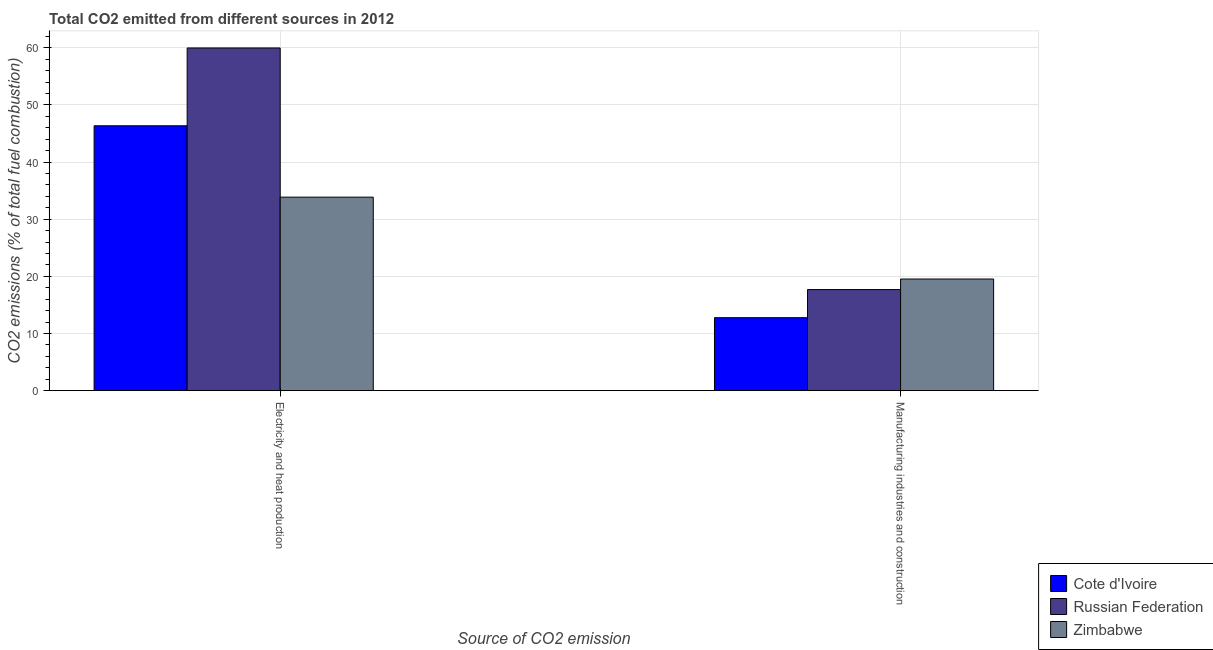How many different coloured bars are there?
Keep it short and to the point. 3. How many groups of bars are there?
Your response must be concise. 2. Are the number of bars per tick equal to the number of legend labels?
Make the answer very short. Yes. Are the number of bars on each tick of the X-axis equal?
Your answer should be very brief. Yes. How many bars are there on the 2nd tick from the right?
Keep it short and to the point. 3. What is the label of the 2nd group of bars from the left?
Offer a very short reply. Manufacturing industries and construction. What is the co2 emissions due to manufacturing industries in Zimbabwe?
Keep it short and to the point. 19.54. Across all countries, what is the maximum co2 emissions due to manufacturing industries?
Give a very brief answer. 19.54. Across all countries, what is the minimum co2 emissions due to electricity and heat production?
Keep it short and to the point. 33.87. In which country was the co2 emissions due to electricity and heat production maximum?
Provide a succinct answer. Russian Federation. In which country was the co2 emissions due to manufacturing industries minimum?
Offer a terse response. Cote d'Ivoire. What is the total co2 emissions due to electricity and heat production in the graph?
Make the answer very short. 140.21. What is the difference between the co2 emissions due to electricity and heat production in Russian Federation and that in Zimbabwe?
Offer a terse response. 26.11. What is the difference between the co2 emissions due to manufacturing industries in Russian Federation and the co2 emissions due to electricity and heat production in Cote d'Ivoire?
Provide a succinct answer. -28.67. What is the average co2 emissions due to manufacturing industries per country?
Keep it short and to the point. 16.67. What is the difference between the co2 emissions due to manufacturing industries and co2 emissions due to electricity and heat production in Zimbabwe?
Your answer should be compact. -14.33. What is the ratio of the co2 emissions due to electricity and heat production in Zimbabwe to that in Cote d'Ivoire?
Your answer should be compact. 0.73. In how many countries, is the co2 emissions due to manufacturing industries greater than the average co2 emissions due to manufacturing industries taken over all countries?
Ensure brevity in your answer.  2. What does the 3rd bar from the left in Electricity and heat production represents?
Give a very brief answer. Zimbabwe. What does the 3rd bar from the right in Manufacturing industries and construction represents?
Give a very brief answer. Cote d'Ivoire. How many countries are there in the graph?
Your answer should be compact. 3. What is the difference between two consecutive major ticks on the Y-axis?
Give a very brief answer. 10. Are the values on the major ticks of Y-axis written in scientific E-notation?
Make the answer very short. No. Does the graph contain any zero values?
Give a very brief answer. No. Does the graph contain grids?
Provide a short and direct response. Yes. How many legend labels are there?
Provide a short and direct response. 3. How are the legend labels stacked?
Ensure brevity in your answer.  Vertical. What is the title of the graph?
Give a very brief answer. Total CO2 emitted from different sources in 2012. What is the label or title of the X-axis?
Your response must be concise. Source of CO2 emission. What is the label or title of the Y-axis?
Make the answer very short. CO2 emissions (% of total fuel combustion). What is the CO2 emissions (% of total fuel combustion) in Cote d'Ivoire in Electricity and heat production?
Your answer should be compact. 46.36. What is the CO2 emissions (% of total fuel combustion) in Russian Federation in Electricity and heat production?
Offer a very short reply. 59.98. What is the CO2 emissions (% of total fuel combustion) of Zimbabwe in Electricity and heat production?
Your answer should be compact. 33.87. What is the CO2 emissions (% of total fuel combustion) of Cote d'Ivoire in Manufacturing industries and construction?
Provide a short and direct response. 12.77. What is the CO2 emissions (% of total fuel combustion) in Russian Federation in Manufacturing industries and construction?
Provide a short and direct response. 17.69. What is the CO2 emissions (% of total fuel combustion) of Zimbabwe in Manufacturing industries and construction?
Your response must be concise. 19.54. Across all Source of CO2 emission, what is the maximum CO2 emissions (% of total fuel combustion) of Cote d'Ivoire?
Ensure brevity in your answer.  46.36. Across all Source of CO2 emission, what is the maximum CO2 emissions (% of total fuel combustion) of Russian Federation?
Your answer should be very brief. 59.98. Across all Source of CO2 emission, what is the maximum CO2 emissions (% of total fuel combustion) in Zimbabwe?
Keep it short and to the point. 33.87. Across all Source of CO2 emission, what is the minimum CO2 emissions (% of total fuel combustion) in Cote d'Ivoire?
Make the answer very short. 12.77. Across all Source of CO2 emission, what is the minimum CO2 emissions (% of total fuel combustion) of Russian Federation?
Ensure brevity in your answer.  17.69. Across all Source of CO2 emission, what is the minimum CO2 emissions (% of total fuel combustion) in Zimbabwe?
Make the answer very short. 19.54. What is the total CO2 emissions (% of total fuel combustion) of Cote d'Ivoire in the graph?
Give a very brief answer. 59.13. What is the total CO2 emissions (% of total fuel combustion) of Russian Federation in the graph?
Give a very brief answer. 77.67. What is the total CO2 emissions (% of total fuel combustion) of Zimbabwe in the graph?
Offer a terse response. 53.41. What is the difference between the CO2 emissions (% of total fuel combustion) in Cote d'Ivoire in Electricity and heat production and that in Manufacturing industries and construction?
Provide a succinct answer. 33.59. What is the difference between the CO2 emissions (% of total fuel combustion) of Russian Federation in Electricity and heat production and that in Manufacturing industries and construction?
Provide a succinct answer. 42.29. What is the difference between the CO2 emissions (% of total fuel combustion) in Zimbabwe in Electricity and heat production and that in Manufacturing industries and construction?
Keep it short and to the point. 14.33. What is the difference between the CO2 emissions (% of total fuel combustion) of Cote d'Ivoire in Electricity and heat production and the CO2 emissions (% of total fuel combustion) of Russian Federation in Manufacturing industries and construction?
Provide a succinct answer. 28.67. What is the difference between the CO2 emissions (% of total fuel combustion) of Cote d'Ivoire in Electricity and heat production and the CO2 emissions (% of total fuel combustion) of Zimbabwe in Manufacturing industries and construction?
Provide a succinct answer. 26.82. What is the difference between the CO2 emissions (% of total fuel combustion) in Russian Federation in Electricity and heat production and the CO2 emissions (% of total fuel combustion) in Zimbabwe in Manufacturing industries and construction?
Make the answer very short. 40.44. What is the average CO2 emissions (% of total fuel combustion) of Cote d'Ivoire per Source of CO2 emission?
Provide a short and direct response. 29.57. What is the average CO2 emissions (% of total fuel combustion) of Russian Federation per Source of CO2 emission?
Offer a very short reply. 38.83. What is the average CO2 emissions (% of total fuel combustion) in Zimbabwe per Source of CO2 emission?
Provide a short and direct response. 26.7. What is the difference between the CO2 emissions (% of total fuel combustion) in Cote d'Ivoire and CO2 emissions (% of total fuel combustion) in Russian Federation in Electricity and heat production?
Your answer should be very brief. -13.62. What is the difference between the CO2 emissions (% of total fuel combustion) in Cote d'Ivoire and CO2 emissions (% of total fuel combustion) in Zimbabwe in Electricity and heat production?
Make the answer very short. 12.49. What is the difference between the CO2 emissions (% of total fuel combustion) of Russian Federation and CO2 emissions (% of total fuel combustion) of Zimbabwe in Electricity and heat production?
Your answer should be very brief. 26.11. What is the difference between the CO2 emissions (% of total fuel combustion) of Cote d'Ivoire and CO2 emissions (% of total fuel combustion) of Russian Federation in Manufacturing industries and construction?
Make the answer very short. -4.92. What is the difference between the CO2 emissions (% of total fuel combustion) of Cote d'Ivoire and CO2 emissions (% of total fuel combustion) of Zimbabwe in Manufacturing industries and construction?
Your response must be concise. -6.77. What is the difference between the CO2 emissions (% of total fuel combustion) in Russian Federation and CO2 emissions (% of total fuel combustion) in Zimbabwe in Manufacturing industries and construction?
Your response must be concise. -1.85. What is the ratio of the CO2 emissions (% of total fuel combustion) in Cote d'Ivoire in Electricity and heat production to that in Manufacturing industries and construction?
Offer a terse response. 3.63. What is the ratio of the CO2 emissions (% of total fuel combustion) in Russian Federation in Electricity and heat production to that in Manufacturing industries and construction?
Offer a terse response. 3.39. What is the ratio of the CO2 emissions (% of total fuel combustion) in Zimbabwe in Electricity and heat production to that in Manufacturing industries and construction?
Your response must be concise. 1.73. What is the difference between the highest and the second highest CO2 emissions (% of total fuel combustion) of Cote d'Ivoire?
Provide a succinct answer. 33.59. What is the difference between the highest and the second highest CO2 emissions (% of total fuel combustion) of Russian Federation?
Make the answer very short. 42.29. What is the difference between the highest and the second highest CO2 emissions (% of total fuel combustion) in Zimbabwe?
Provide a short and direct response. 14.33. What is the difference between the highest and the lowest CO2 emissions (% of total fuel combustion) of Cote d'Ivoire?
Give a very brief answer. 33.59. What is the difference between the highest and the lowest CO2 emissions (% of total fuel combustion) in Russian Federation?
Your response must be concise. 42.29. What is the difference between the highest and the lowest CO2 emissions (% of total fuel combustion) in Zimbabwe?
Your response must be concise. 14.33. 